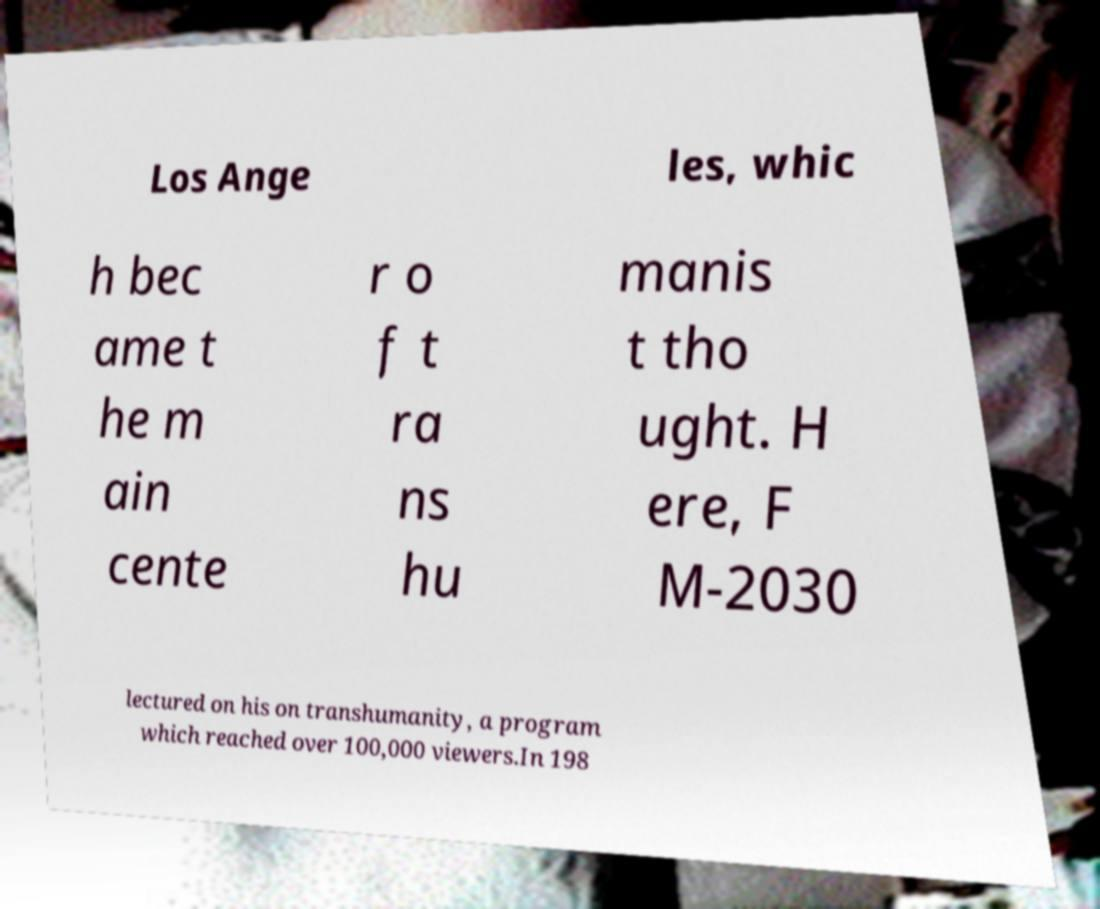Could you assist in decoding the text presented in this image and type it out clearly? Los Ange les, whic h bec ame t he m ain cente r o f t ra ns hu manis t tho ught. H ere, F M-2030 lectured on his on transhumanity, a program which reached over 100,000 viewers.In 198 